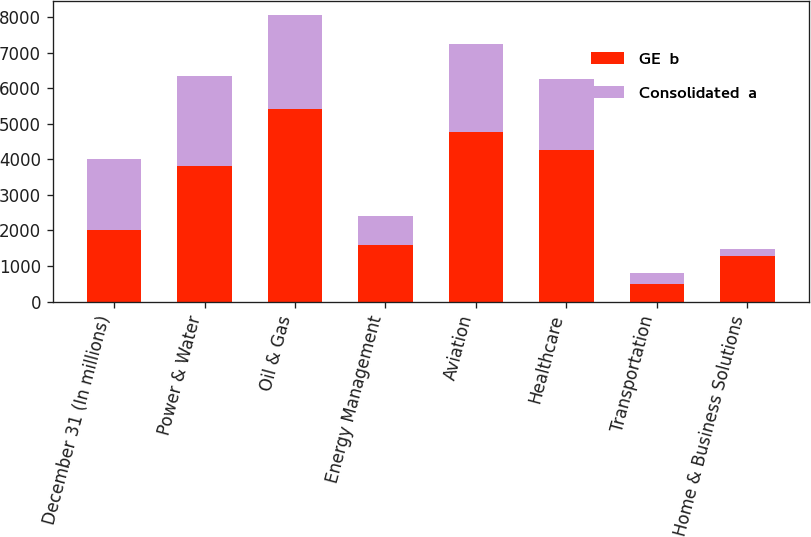Convert chart to OTSL. <chart><loc_0><loc_0><loc_500><loc_500><stacked_bar_chart><ecel><fcel>December 31 (In millions)<fcel>Power & Water<fcel>Oil & Gas<fcel>Energy Management<fcel>Aviation<fcel>Healthcare<fcel>Transportation<fcel>Home & Business Solutions<nl><fcel>GE  b<fcel>2012<fcel>3809<fcel>5421<fcel>1600<fcel>4756<fcel>4253<fcel>485<fcel>1286<nl><fcel>Consolidated  a<fcel>2012<fcel>2532<fcel>2637<fcel>800<fcel>2493<fcel>2012<fcel>324<fcel>186<nl></chart> 